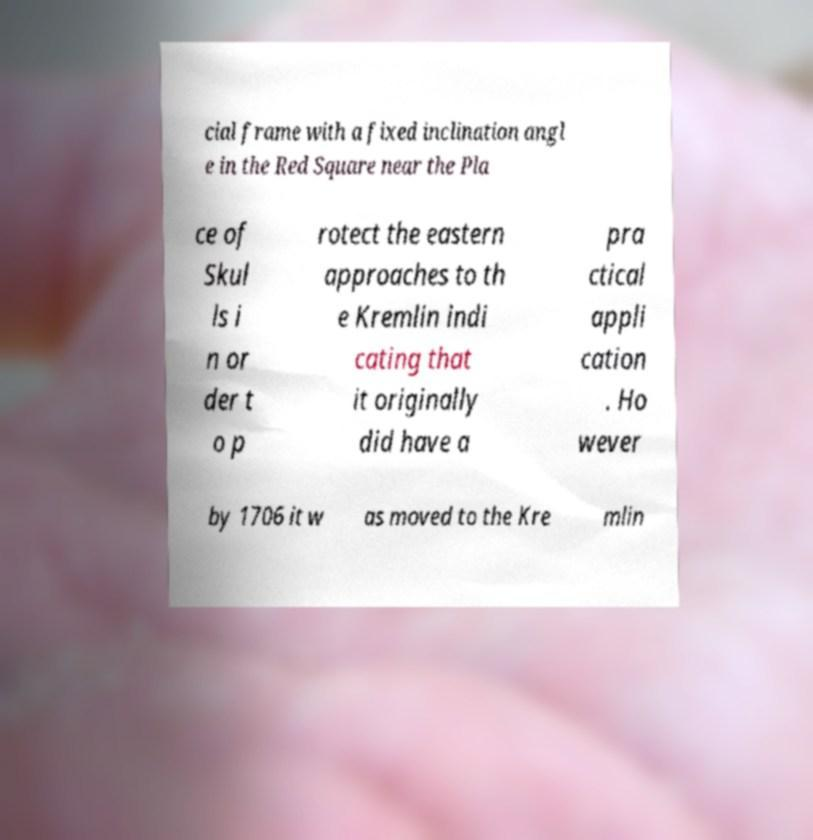Please read and relay the text visible in this image. What does it say? cial frame with a fixed inclination angl e in the Red Square near the Pla ce of Skul ls i n or der t o p rotect the eastern approaches to th e Kremlin indi cating that it originally did have a pra ctical appli cation . Ho wever by 1706 it w as moved to the Kre mlin 